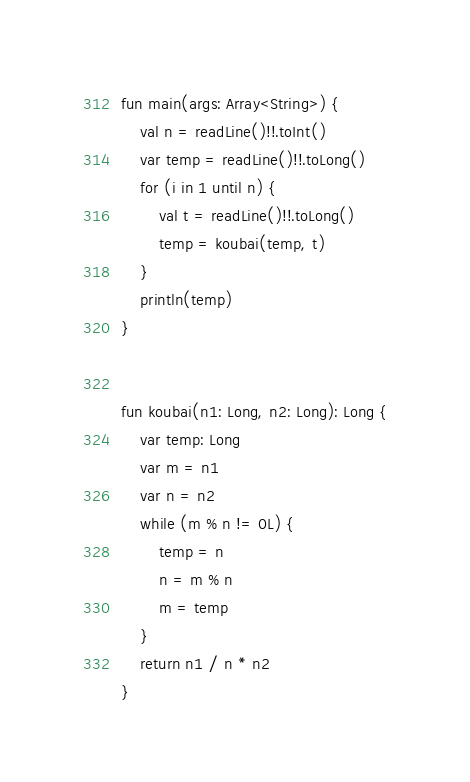<code> <loc_0><loc_0><loc_500><loc_500><_Kotlin_>fun main(args: Array<String>) {
    val n = readLine()!!.toInt()
    var temp = readLine()!!.toLong()
    for (i in 1 until n) {
        val t = readLine()!!.toLong()
        temp = koubai(temp, t)
    }
    println(temp)
}


fun koubai(n1: Long, n2: Long): Long {
    var temp: Long
    var m = n1
    var n = n2
    while (m % n != 0L) {
        temp = n
        n = m % n
        m = temp
    }
    return n1 / n * n2
}

</code> 